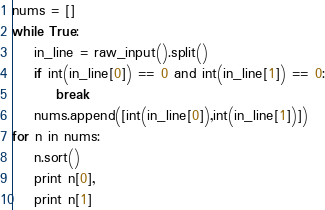<code> <loc_0><loc_0><loc_500><loc_500><_Python_>nums = []
while True:
    in_line = raw_input().split()
    if int(in_line[0]) == 0 and int(in_line[1]) == 0:
        break
    nums.append([int(in_line[0]),int(in_line[1])])
for n in nums:
    n.sort()
    print n[0],
    print n[1]</code> 